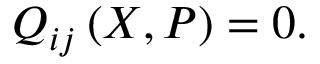<formula> <loc_0><loc_0><loc_500><loc_500>Q _ { i j } \left ( X , P \right ) = 0 .</formula> 